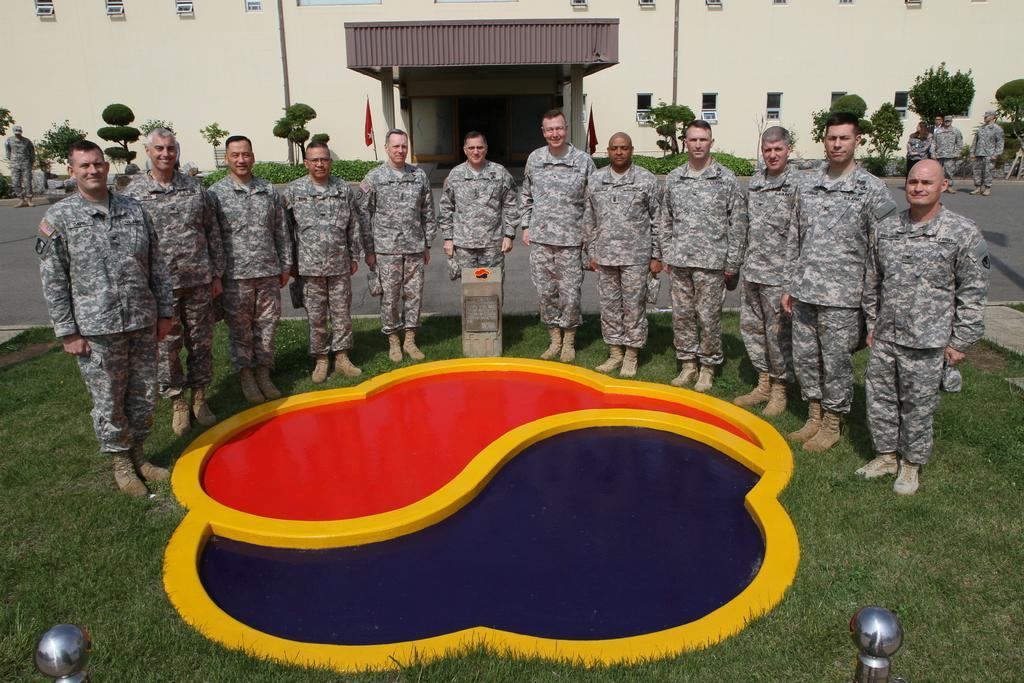Could you give a brief overview of what you see in this image? In this image we can see a group of people wearing military uniforms are standing on the ground. In the foreground we can see are on the ground, some metal poles, statue and in the background, we can see a building with a group of windows, shed, flags, group of trees and plants. 